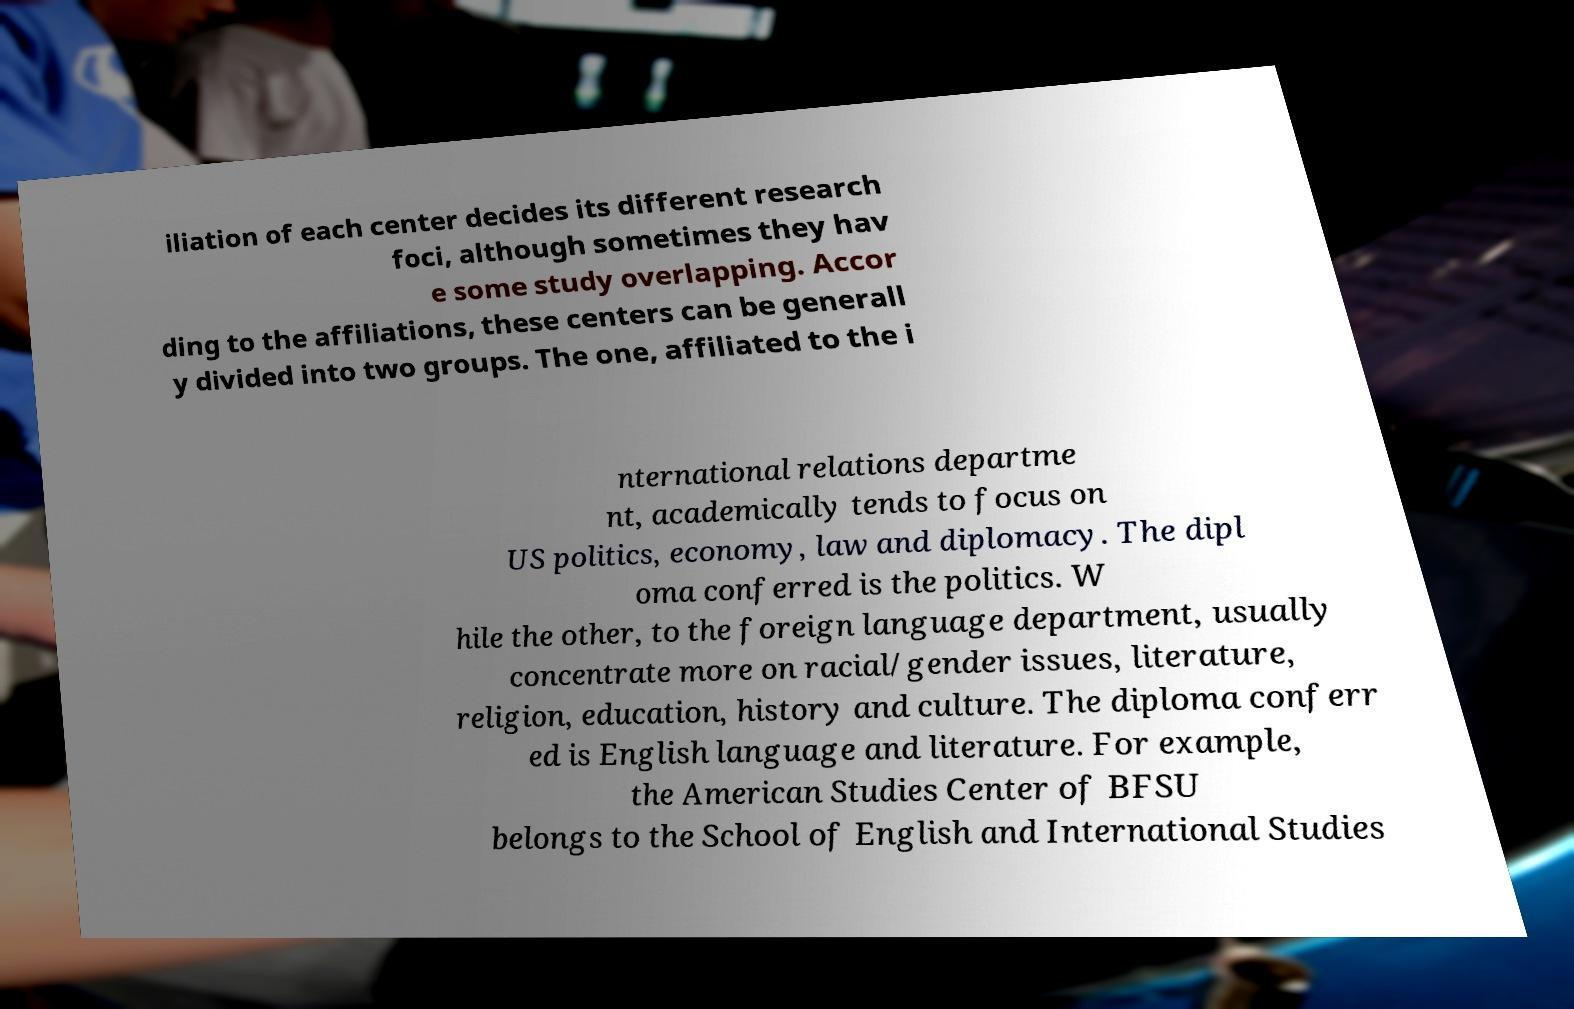Could you extract and type out the text from this image? iliation of each center decides its different research foci, although sometimes they hav e some study overlapping. Accor ding to the affiliations, these centers can be generall y divided into two groups. The one, affiliated to the i nternational relations departme nt, academically tends to focus on US politics, economy, law and diplomacy. The dipl oma conferred is the politics. W hile the other, to the foreign language department, usually concentrate more on racial/gender issues, literature, religion, education, history and culture. The diploma conferr ed is English language and literature. For example, the American Studies Center of BFSU belongs to the School of English and International Studies 